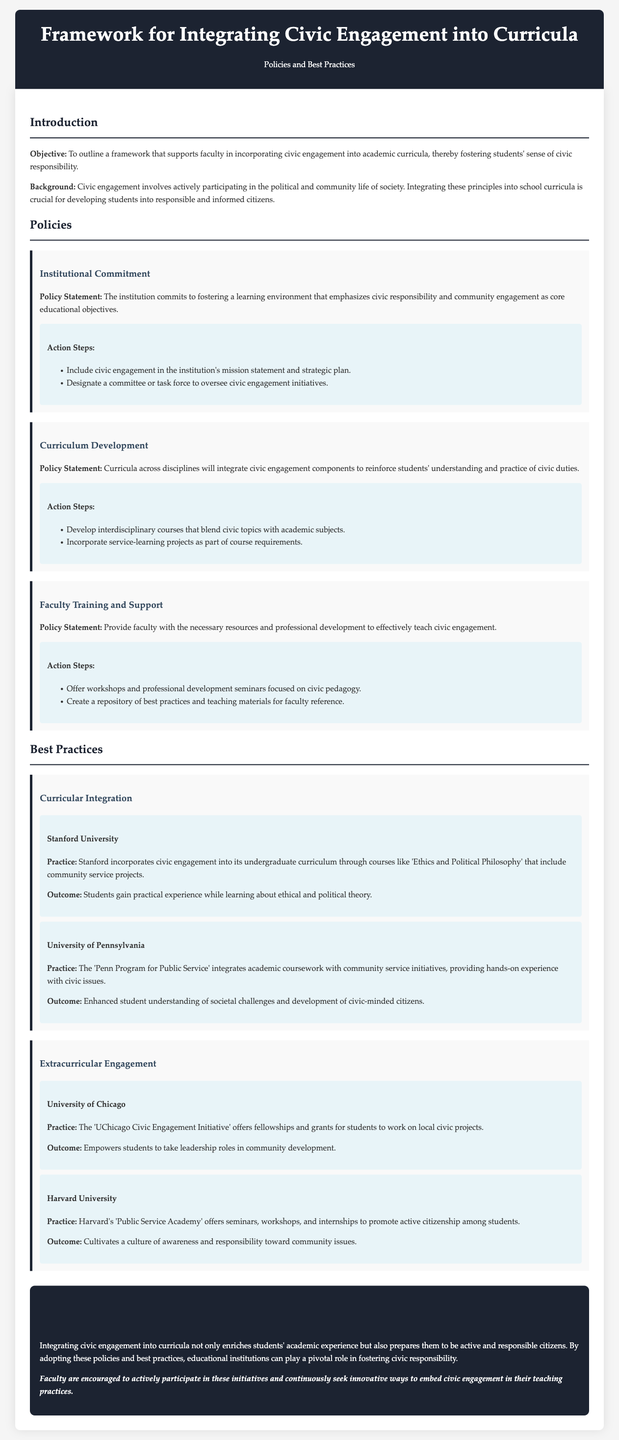What is the objective of the framework? The objective is to outline a framework that supports faculty in incorporating civic engagement into academic curricula, thereby fostering students' sense of civic responsibility.
Answer: To outline a framework that supports faculty in incorporating civic engagement into academic curricula, thereby fostering students' sense of civic responsibility What are the two action steps for Institutional Commitment? The action steps include including civic engagement in the institution's mission statement and strategic plan, and designating a committee or task force to oversee civic engagement initiatives.
Answer: Include civic engagement in the institution's mission statement and strategic plan; designate a committee or task force What is one practice from Stanford University mentioned? Stanford incorporates civic engagement into its undergraduate curriculum through courses like 'Ethics and Political Philosophy' that include community service projects.
Answer: Courses like 'Ethics and Political Philosophy' that include community service projects How does Harvard promote active citizenship? Harvard's 'Public Service Academy' offers seminars, workshops, and internships to promote active citizenship among students.
Answer: Offers seminars, workshops, and internships What is one outcome of the 'UChicago Civic Engagement Initiative'? The outcome is empowering students to take leadership roles in community development.
Answer: Empowers students to take leadership roles in community development What is the core educational objective emphasized by the institution? The institution emphasizes civic responsibility and community engagement as core educational objectives.
Answer: Civic responsibility and community engagement What type of projects are incorporated into the curriculum according to the Policy on Curriculum Development? The policy states to incorporate service-learning projects as part of course requirements.
Answer: Service-learning projects What does the conclusion suggest for faculty? Faculty are encouraged to actively participate in these initiatives and continuously seek innovative ways to embed civic engagement in their teaching practices.
Answer: Actively participate and seek innovative ways to embed civic engagement 